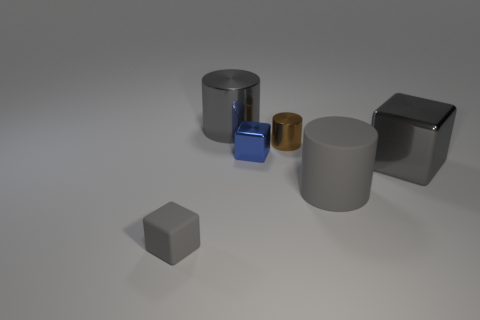There is another tiny shiny object that is the same shape as the tiny gray object; what color is it?
Provide a succinct answer. Blue. Is the number of gray metallic blocks behind the blue metallic cube greater than the number of brown cylinders that are in front of the small brown shiny thing?
Ensure brevity in your answer.  No. How big is the gray matte object that is on the left side of the large gray cylinder that is right of the big gray cylinder that is behind the blue object?
Your response must be concise. Small. Is the tiny brown cylinder made of the same material as the gray block to the left of the small brown shiny cylinder?
Ensure brevity in your answer.  No. Is the shape of the small gray thing the same as the blue metal object?
Your answer should be very brief. Yes. How many other things are made of the same material as the small blue thing?
Provide a succinct answer. 3. What number of small blue objects are the same shape as the large gray rubber thing?
Your answer should be compact. 0. There is a big object that is both in front of the brown cylinder and left of the large gray block; what is its color?
Provide a short and direct response. Gray. What number of tiny gray cylinders are there?
Provide a short and direct response. 0. Is the rubber cube the same size as the blue metal cube?
Keep it short and to the point. Yes. 